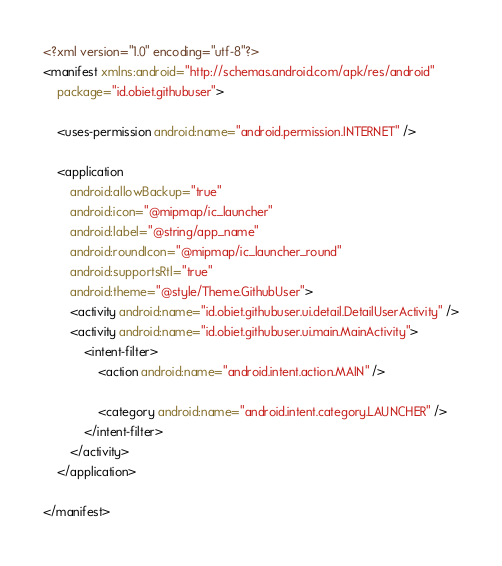<code> <loc_0><loc_0><loc_500><loc_500><_XML_><?xml version="1.0" encoding="utf-8"?>
<manifest xmlns:android="http://schemas.android.com/apk/res/android"
    package="id.obiet.githubuser">

    <uses-permission android:name="android.permission.INTERNET" />

    <application
        android:allowBackup="true"
        android:icon="@mipmap/ic_launcher"
        android:label="@string/app_name"
        android:roundIcon="@mipmap/ic_launcher_round"
        android:supportsRtl="true"
        android:theme="@style/Theme.GithubUser">
        <activity android:name="id.obiet.githubuser.ui.detail.DetailUserActivity" />
        <activity android:name="id.obiet.githubuser.ui.main.MainActivity">
            <intent-filter>
                <action android:name="android.intent.action.MAIN" />

                <category android:name="android.intent.category.LAUNCHER" />
            </intent-filter>
        </activity>
    </application>

</manifest></code> 